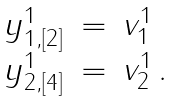<formula> <loc_0><loc_0><loc_500><loc_500>\begin{array} { c c l } y _ { 1 , [ 2 ] } ^ { 1 } & = & v _ { 1 } ^ { 1 } \\ y _ { 2 , [ 4 ] } ^ { 1 } & = & v _ { 2 } ^ { 1 } \, . \end{array}</formula> 